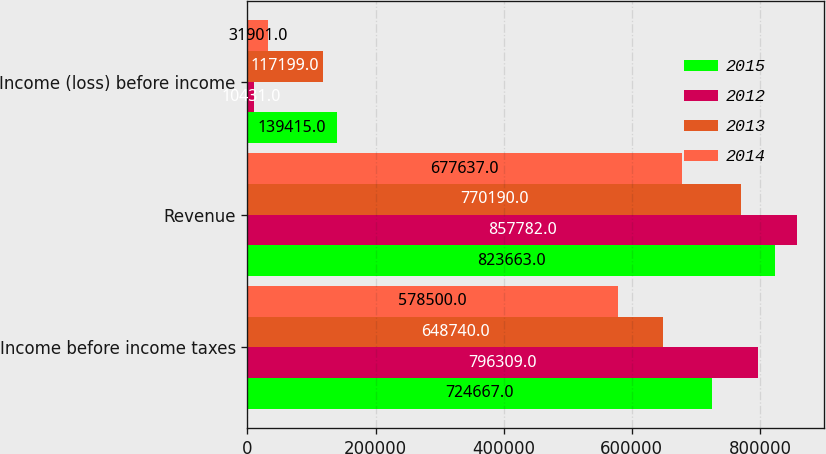Convert chart. <chart><loc_0><loc_0><loc_500><loc_500><stacked_bar_chart><ecel><fcel>Income before income taxes<fcel>Revenue<fcel>Income (loss) before income<nl><fcel>2015<fcel>724667<fcel>823663<fcel>139415<nl><fcel>2012<fcel>796309<fcel>857782<fcel>10431<nl><fcel>2013<fcel>648740<fcel>770190<fcel>117199<nl><fcel>2014<fcel>578500<fcel>677637<fcel>31901<nl></chart> 